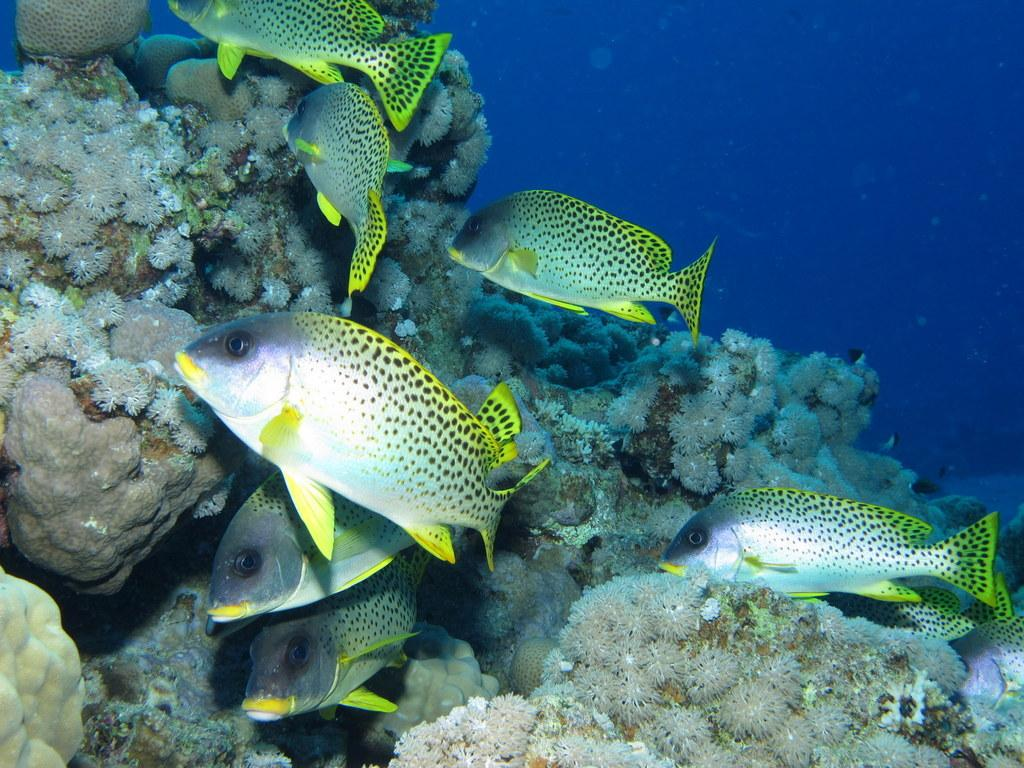What type of animals can be seen in the image? There are fishes in the image. Where are the fishes located? The fishes are in water. What color is the orange that the fishes are holding in the image? There is no orange present in the image, as the fishes are in water and do not have the ability to hold objects. 